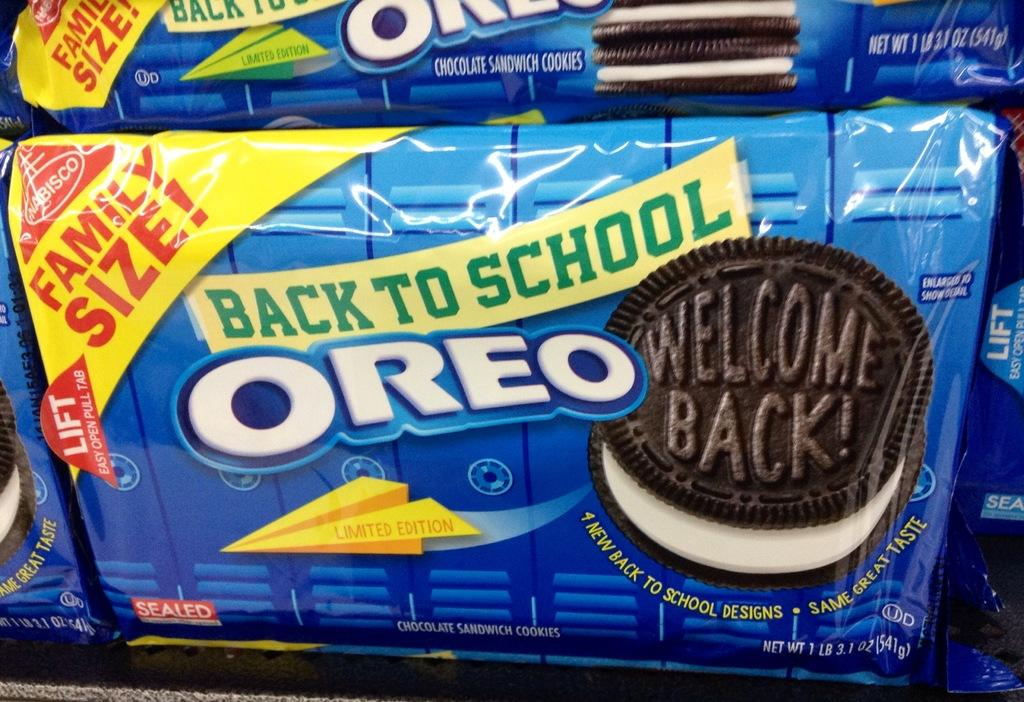<image>
Render a clear and concise summary of the photo. a package of back to school oreos, family size! 